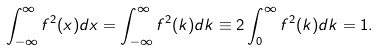Convert formula to latex. <formula><loc_0><loc_0><loc_500><loc_500>\int _ { - \infty } ^ { \infty } f ^ { 2 } ( x ) d x = \int _ { - \infty } ^ { \infty } f ^ { 2 } ( k ) d k \equiv 2 \int _ { 0 } ^ { \infty } f ^ { 2 } ( k ) d k = 1 .</formula> 